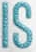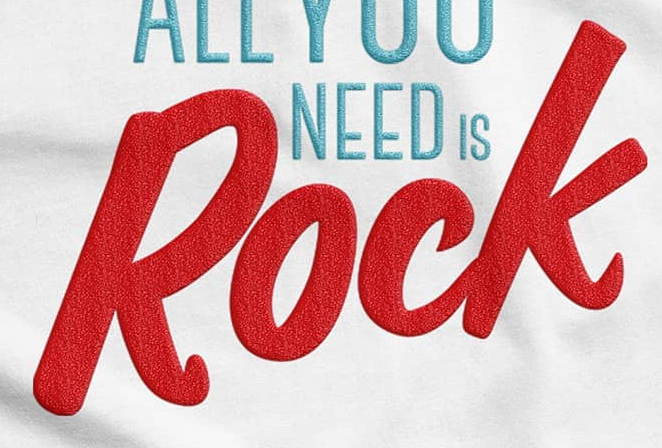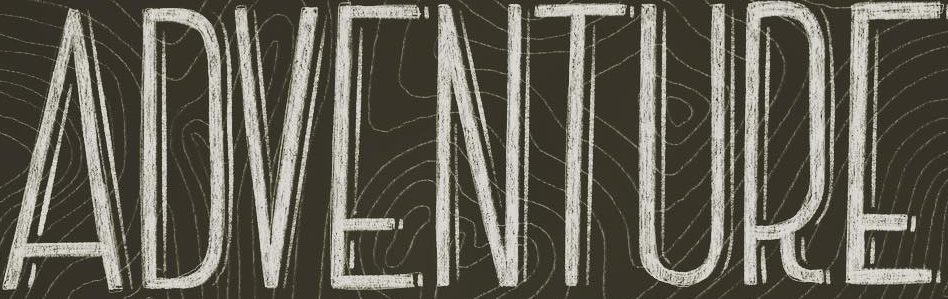What text appears in these images from left to right, separated by a semicolon? IS; Rock; ADVENTURE 